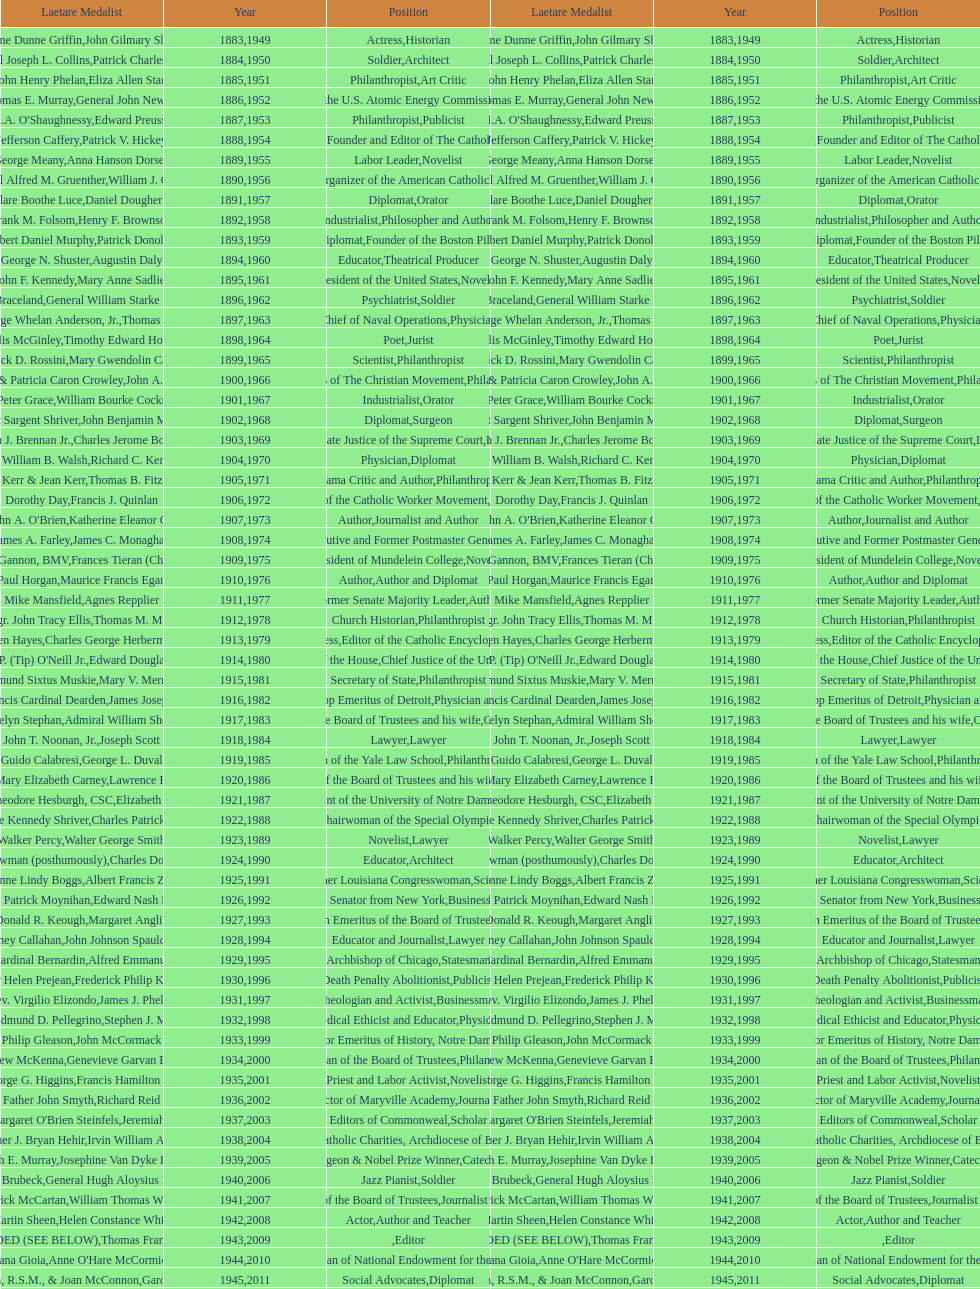What is the name of the laetare medalist listed before edward preuss? General John Newton. 